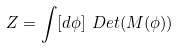<formula> <loc_0><loc_0><loc_500><loc_500>Z = \int [ d \phi ] \ D e t ( M ( \phi ) )</formula> 